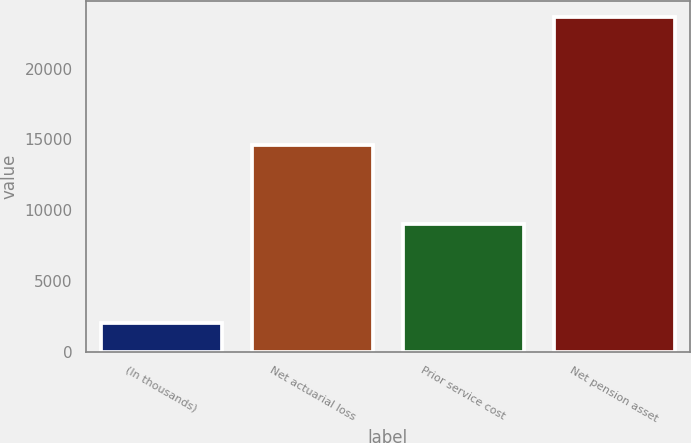Convert chart. <chart><loc_0><loc_0><loc_500><loc_500><bar_chart><fcel>(In thousands)<fcel>Net actuarial loss<fcel>Prior service cost<fcel>Net pension asset<nl><fcel>2012<fcel>14605<fcel>9012<fcel>23617<nl></chart> 